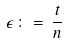<formula> <loc_0><loc_0><loc_500><loc_500>\epsilon \, \colon = \, \frac { t } { n }</formula> 